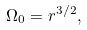Convert formula to latex. <formula><loc_0><loc_0><loc_500><loc_500>\Omega _ { 0 } = r ^ { 3 / 2 } ,</formula> 